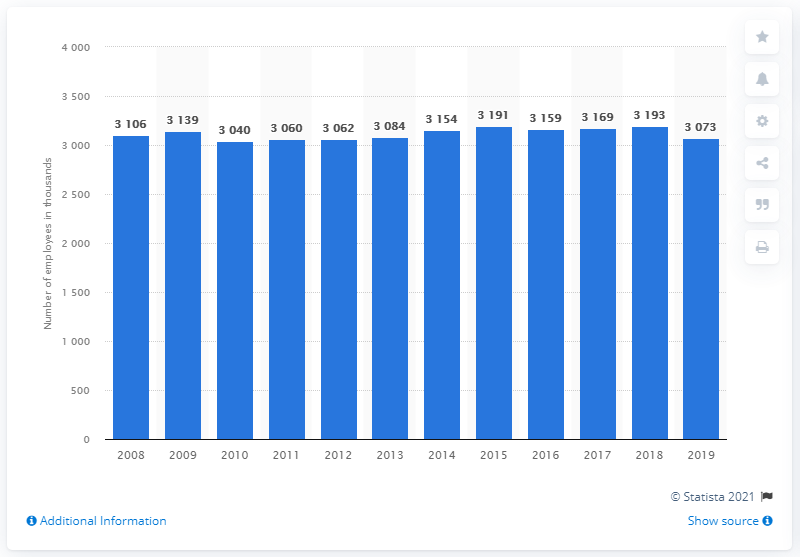Mention a couple of crucial points in this snapshot. In 2008, the average total employment in retail trade in the United Kingdom was recorded. 